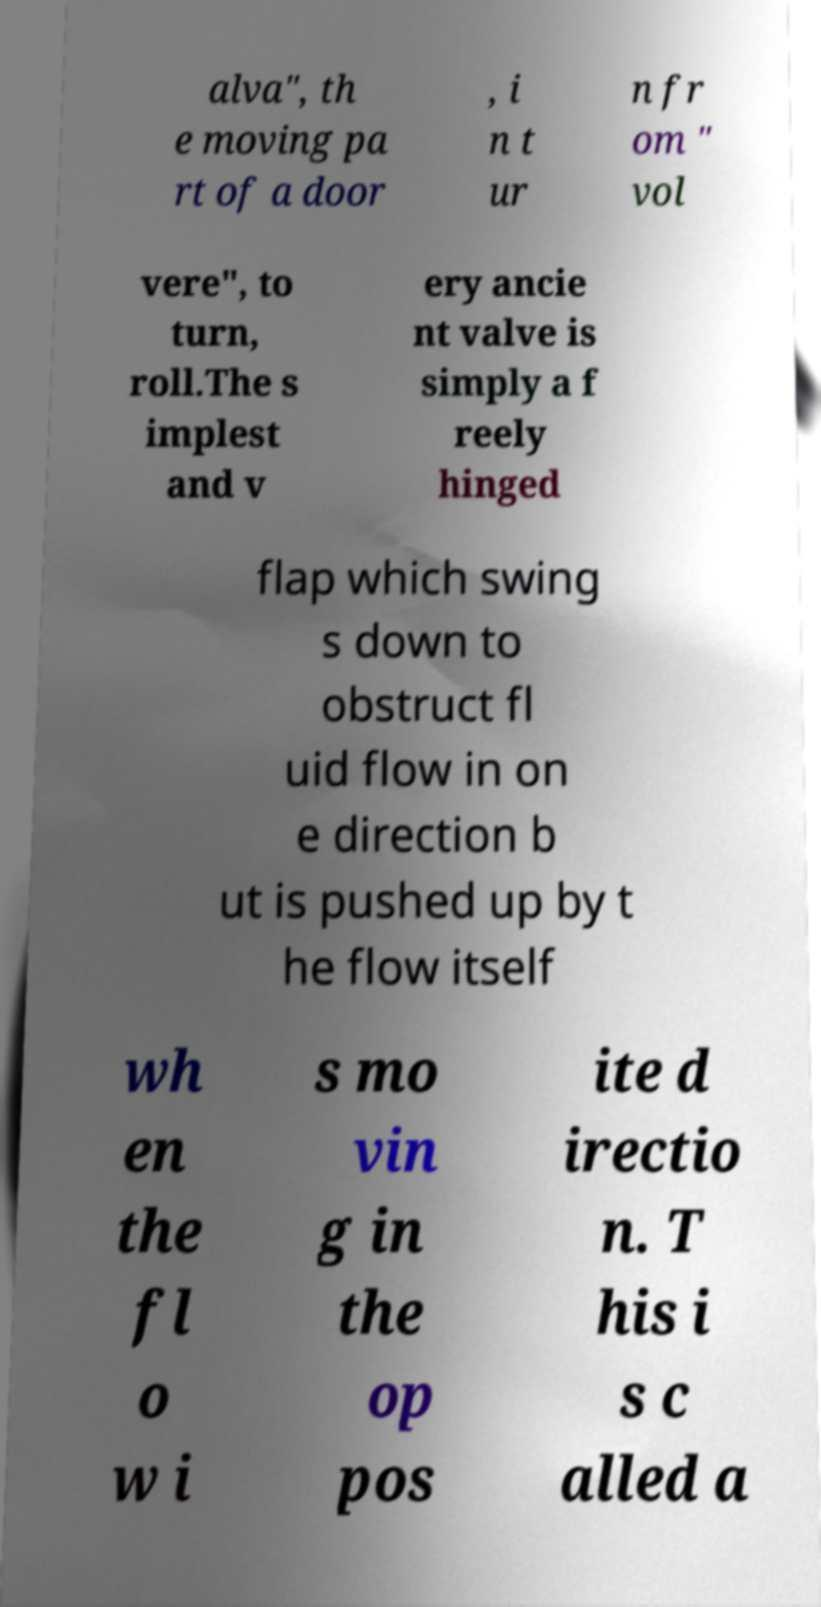Could you extract and type out the text from this image? alva", th e moving pa rt of a door , i n t ur n fr om " vol vere", to turn, roll.The s implest and v ery ancie nt valve is simply a f reely hinged flap which swing s down to obstruct fl uid flow in on e direction b ut is pushed up by t he flow itself wh en the fl o w i s mo vin g in the op pos ite d irectio n. T his i s c alled a 